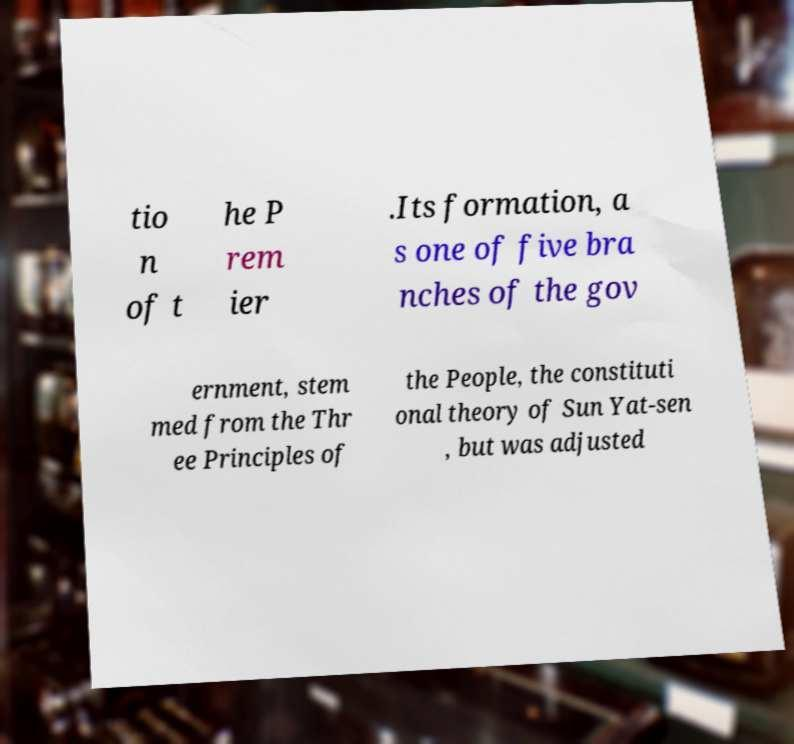There's text embedded in this image that I need extracted. Can you transcribe it verbatim? tio n of t he P rem ier .Its formation, a s one of five bra nches of the gov ernment, stem med from the Thr ee Principles of the People, the constituti onal theory of Sun Yat-sen , but was adjusted 